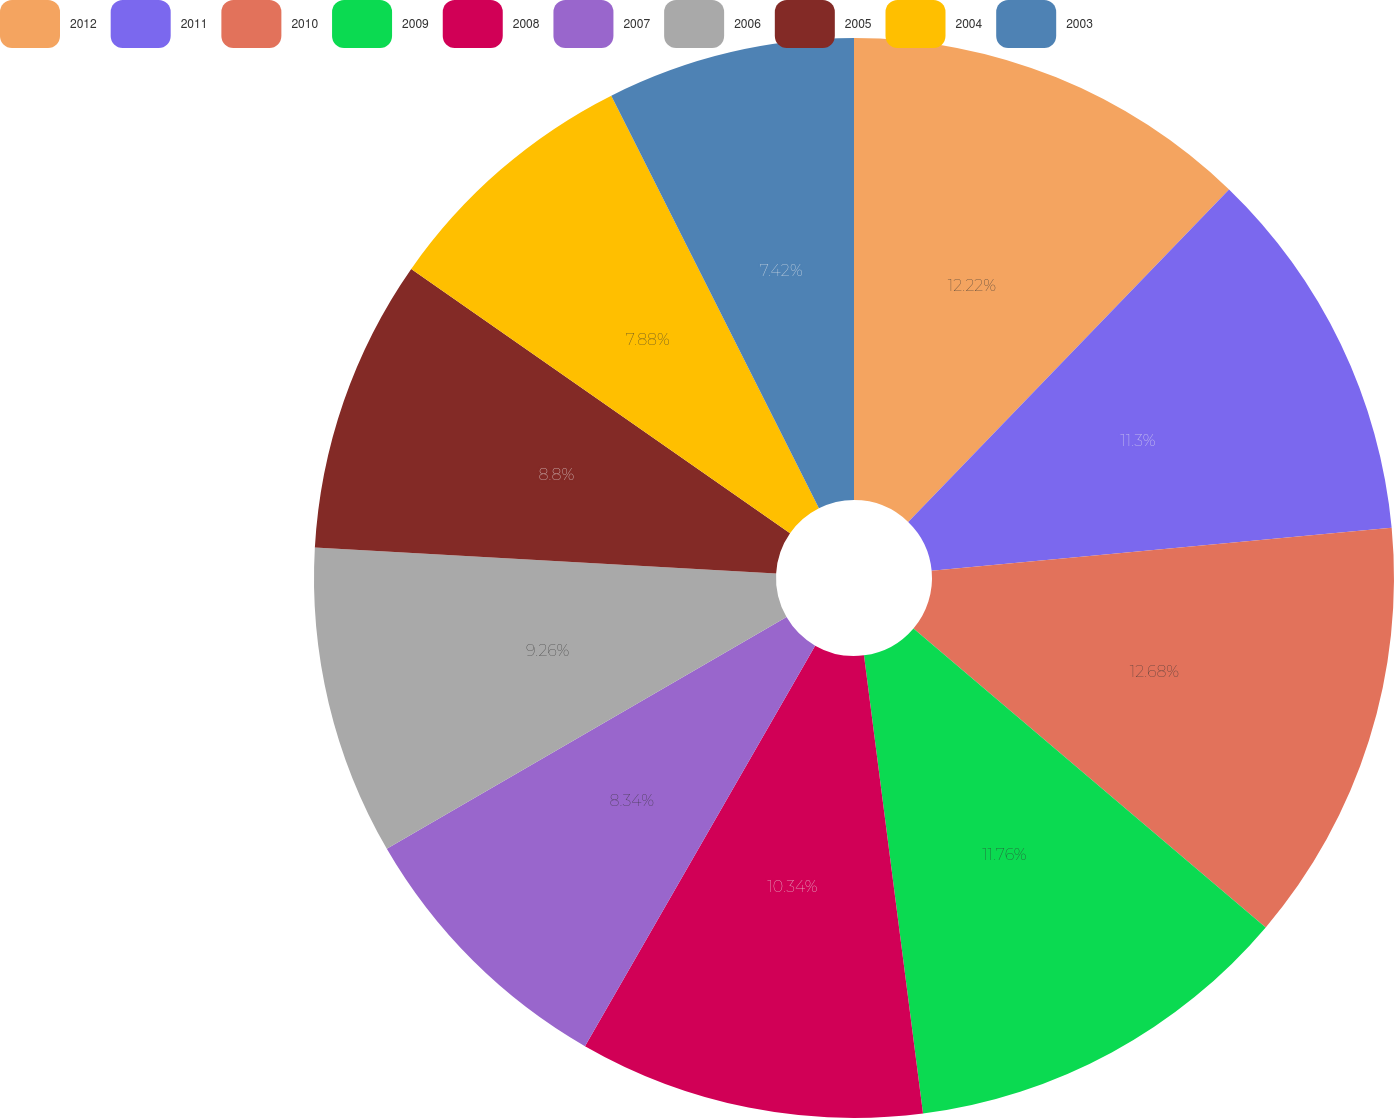<chart> <loc_0><loc_0><loc_500><loc_500><pie_chart><fcel>2012<fcel>2011<fcel>2010<fcel>2009<fcel>2008<fcel>2007<fcel>2006<fcel>2005<fcel>2004<fcel>2003<nl><fcel>12.22%<fcel>11.3%<fcel>12.68%<fcel>11.76%<fcel>10.34%<fcel>8.34%<fcel>9.26%<fcel>8.8%<fcel>7.88%<fcel>7.42%<nl></chart> 